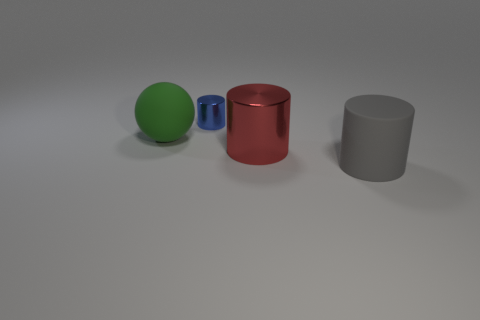Subtract all metal cylinders. How many cylinders are left? 1 Subtract all spheres. How many objects are left? 3 Subtract 2 cylinders. How many cylinders are left? 1 Add 1 tiny cyan shiny blocks. How many objects exist? 5 Subtract all green cylinders. Subtract all brown spheres. How many cylinders are left? 3 Subtract all blue cubes. How many red cylinders are left? 1 Subtract all tiny metal cylinders. Subtract all metallic objects. How many objects are left? 1 Add 1 big red cylinders. How many big red cylinders are left? 2 Add 3 tiny blue things. How many tiny blue things exist? 4 Subtract all blue cylinders. How many cylinders are left? 2 